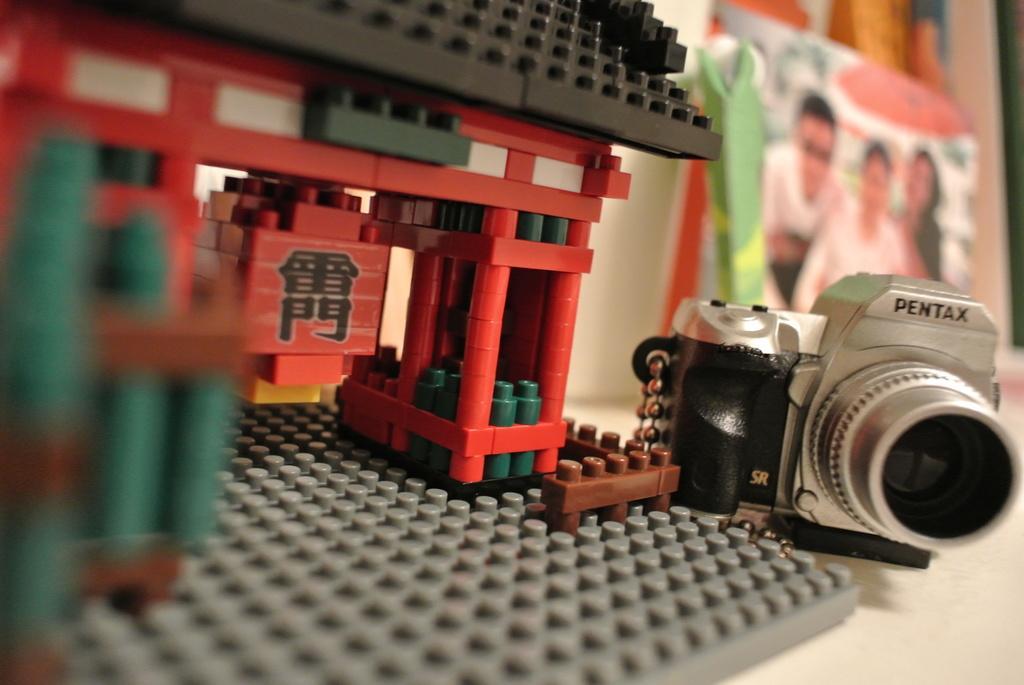Can you describe this image briefly? At the bottom of the image there is a table and we can see lego toy, camera and a bag placed on the table. 